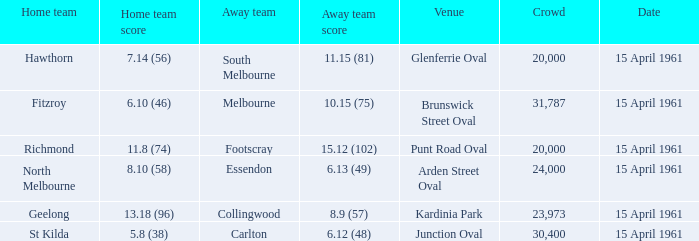What was the score for the home team St Kilda? 5.8 (38). 